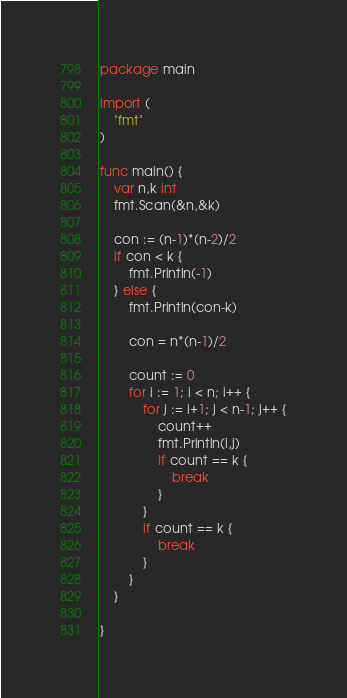<code> <loc_0><loc_0><loc_500><loc_500><_Go_>package main

import (
	"fmt"
)

func main() {
	var n,k int
	fmt.Scan(&n,&k)

	con := (n-1)*(n-2)/2
	if con < k {
		fmt.Println(-1)
	} else {
		fmt.Println(con-k)
		
		con = n*(n-1)/2
		
		count := 0
		for i := 1; i < n; i++ {
			for j := i+1; j < n-1; j++ {
				count++
				fmt.Println(i,j)
				if count == k {
					break
				}
			}
			if count == k {
				break
			}
		}
	}

}
</code> 